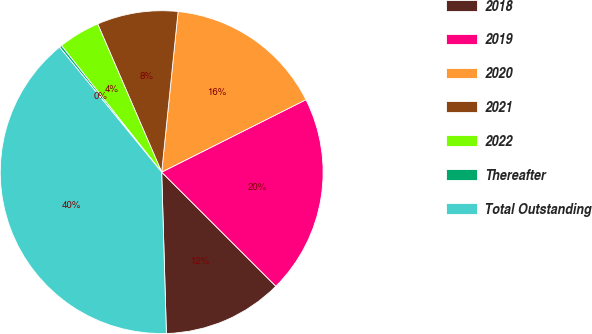Convert chart to OTSL. <chart><loc_0><loc_0><loc_500><loc_500><pie_chart><fcel>2018<fcel>2019<fcel>2020<fcel>2021<fcel>2022<fcel>Thereafter<fcel>Total Outstanding<nl><fcel>12.04%<fcel>19.9%<fcel>15.97%<fcel>8.11%<fcel>4.17%<fcel>0.24%<fcel>39.56%<nl></chart> 